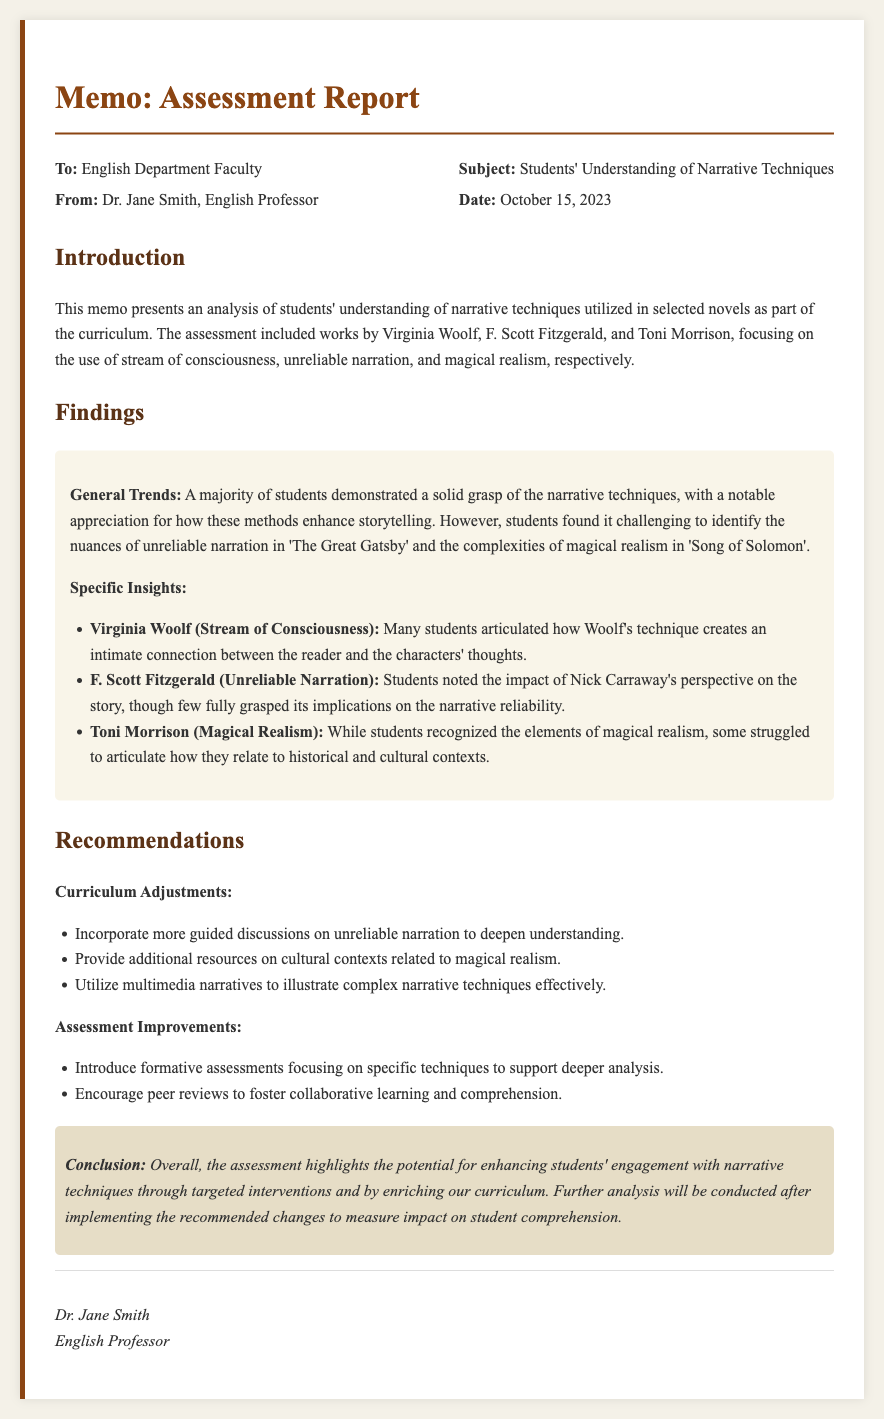What is the date of the memo? The date of the memo is stated in the header section of the document.
Answer: October 15, 2023 Who is the author of the memo? The author of the memo is mentioned at the end of the document.
Answer: Dr. Jane Smith What narrative technique is discussed in relation to Virginia Woolf? This information can be found in the specific insights section detailing each author's narrative technique.
Answer: Stream of Consciousness What is one recommendation for curriculum adjustments? Recommendations for curriculum adjustments are listed in the recommendations section.
Answer: Guided discussions on unreliable narration Which novel features unreliable narration as mentioned in the findings? This novel is specified in the insights about narrative techniques.
Answer: The Great Gatsby How many authors' works are analyzed in the assessment report? The number of authors whose works are covered is mentioned at the beginning of the document.
Answer: Three What do students struggle to articulate regarding Toni Morrison's work? This struggle is noted in the specific insights section regarding the narrative technique of Morrison's work.
Answer: Historical and cultural contexts What is the main conclusion of the assessment report? The conclusion summarizes the overall outcome of the assessment as discussed in the conclusion section.
Answer: Enhancing students' engagement with narrative techniques What type of document is this? The document is characterized by its formal structure and content focused on assessment.
Answer: Memo 